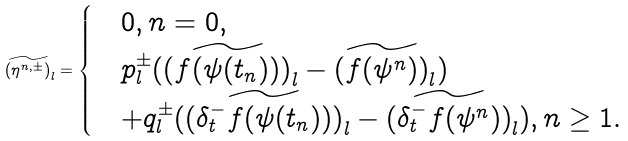Convert formula to latex. <formula><loc_0><loc_0><loc_500><loc_500>\widetilde { ( \eta ^ { n , \pm } ) } _ { l } = \begin{cases} & 0 , n = 0 , \\ & p _ { l } ^ { \pm } ( \widetilde { ( f ( \psi ( t _ { n } ) ) ) } _ { l } - \widetilde { ( f ( \psi ^ { n } ) ) } _ { l } ) \\ & + q _ { l } ^ { \pm } ( \widetilde { ( \delta _ { t } ^ { - } f ( \psi ( t _ { n } ) ) ) } _ { l } - \widetilde { ( \delta _ { t } ^ { - } f ( \psi ^ { n } ) ) } _ { l } ) , n \geq 1 . \end{cases}</formula> 